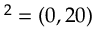<formula> <loc_0><loc_0><loc_500><loc_500>{ \ v O } ^ { 2 } = ( 0 , 2 0 )</formula> 